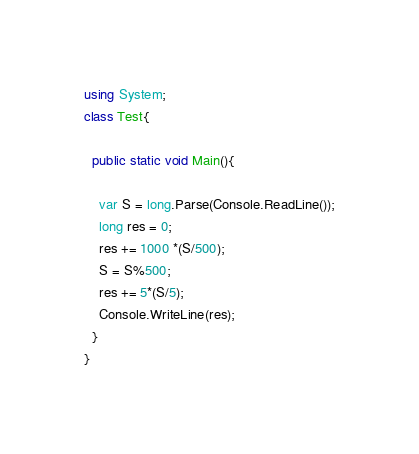<code> <loc_0><loc_0><loc_500><loc_500><_C#_>using System;
class Test{
 
  public static void Main(){
    
    var S = long.Parse(Console.ReadLine());
    long res = 0;
    res += 1000 *(S/500);
    S = S%500;
    res += 5*(S/5);
    Console.WriteLine(res);
  }
}</code> 